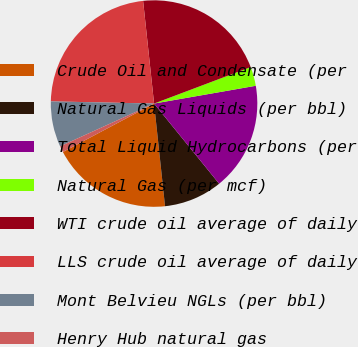<chart> <loc_0><loc_0><loc_500><loc_500><pie_chart><fcel>Crude Oil and Condensate (per<fcel>Natural Gas Liquids (per bbl)<fcel>Total Liquid Hydrocarbons (per<fcel>Natural Gas (per mcf)<fcel>WTI crude oil average of daily<fcel>LLS crude oil average of daily<fcel>Mont Belvieu NGLs (per bbl)<fcel>Henry Hub natural gas<nl><fcel>18.92%<fcel>9.16%<fcel>16.9%<fcel>2.99%<fcel>20.95%<fcel>22.97%<fcel>7.14%<fcel>0.97%<nl></chart> 